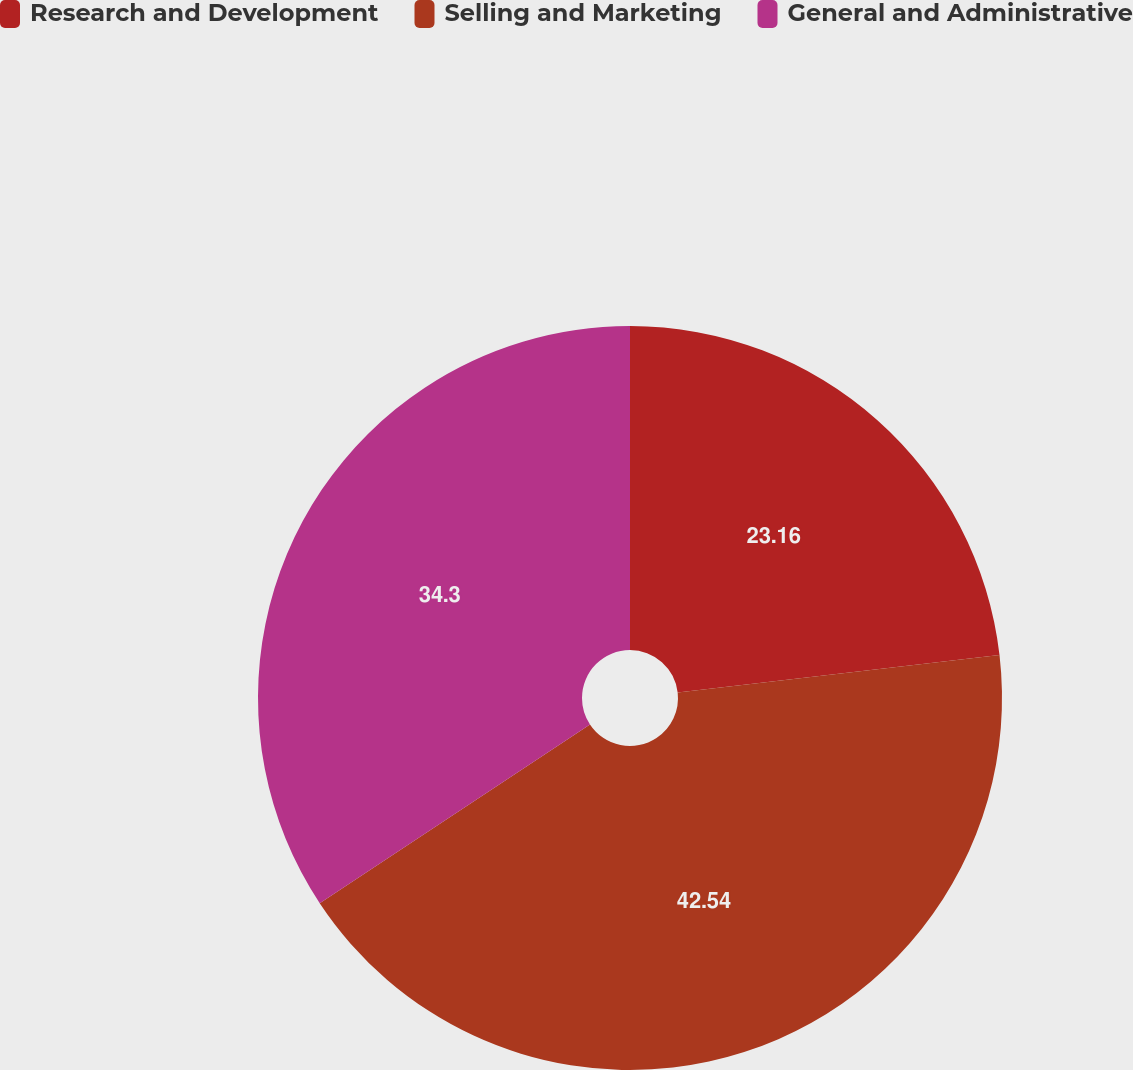<chart> <loc_0><loc_0><loc_500><loc_500><pie_chart><fcel>Research and Development<fcel>Selling and Marketing<fcel>General and Administrative<nl><fcel>23.16%<fcel>42.54%<fcel>34.3%<nl></chart> 